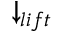<formula> <loc_0><loc_0><loc_500><loc_500>\downarrow _ { l i f t }</formula> 